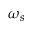Convert formula to latex. <formula><loc_0><loc_0><loc_500><loc_500>\omega _ { s }</formula> 